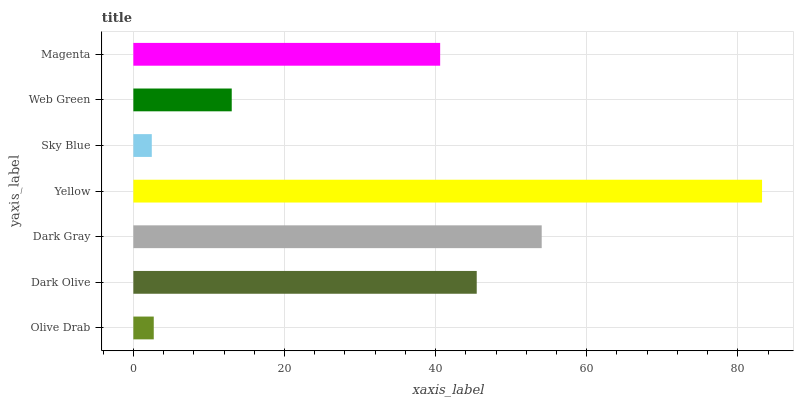Is Sky Blue the minimum?
Answer yes or no. Yes. Is Yellow the maximum?
Answer yes or no. Yes. Is Dark Olive the minimum?
Answer yes or no. No. Is Dark Olive the maximum?
Answer yes or no. No. Is Dark Olive greater than Olive Drab?
Answer yes or no. Yes. Is Olive Drab less than Dark Olive?
Answer yes or no. Yes. Is Olive Drab greater than Dark Olive?
Answer yes or no. No. Is Dark Olive less than Olive Drab?
Answer yes or no. No. Is Magenta the high median?
Answer yes or no. Yes. Is Magenta the low median?
Answer yes or no. Yes. Is Dark Olive the high median?
Answer yes or no. No. Is Dark Olive the low median?
Answer yes or no. No. 